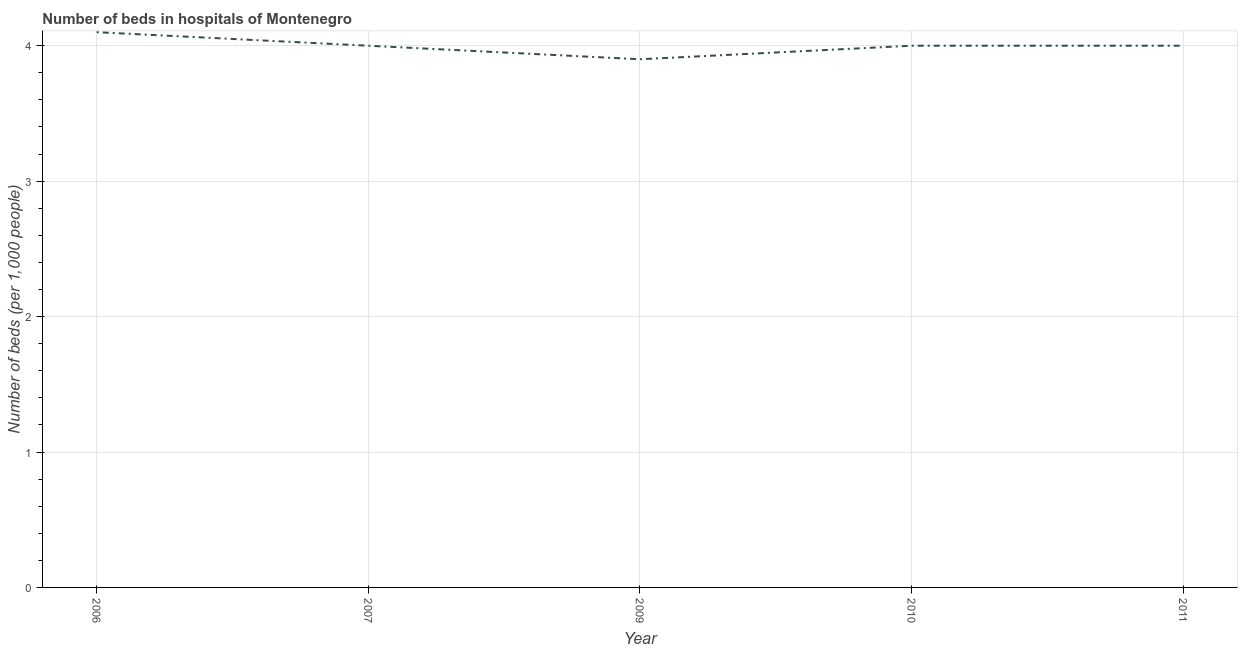What is the number of hospital beds in 2009?
Give a very brief answer. 3.9. In which year was the number of hospital beds maximum?
Keep it short and to the point. 2006. Do a majority of the years between 2010 and 2006 (inclusive) have number of hospital beds greater than 2 %?
Offer a very short reply. Yes. What is the ratio of the number of hospital beds in 2006 to that in 2010?
Offer a terse response. 1.02. What is the difference between the highest and the second highest number of hospital beds?
Give a very brief answer. 0.1. What is the difference between the highest and the lowest number of hospital beds?
Your answer should be very brief. 0.2. In how many years, is the number of hospital beds greater than the average number of hospital beds taken over all years?
Keep it short and to the point. 1. Does the number of hospital beds monotonically increase over the years?
Your answer should be very brief. No. How many lines are there?
Your answer should be very brief. 1. What is the difference between two consecutive major ticks on the Y-axis?
Keep it short and to the point. 1. Are the values on the major ticks of Y-axis written in scientific E-notation?
Ensure brevity in your answer.  No. Does the graph contain any zero values?
Make the answer very short. No. What is the title of the graph?
Keep it short and to the point. Number of beds in hospitals of Montenegro. What is the label or title of the X-axis?
Provide a short and direct response. Year. What is the label or title of the Y-axis?
Offer a very short reply. Number of beds (per 1,0 people). What is the Number of beds (per 1,000 people) in 2006?
Make the answer very short. 4.1. What is the Number of beds (per 1,000 people) of 2007?
Keep it short and to the point. 4. What is the Number of beds (per 1,000 people) in 2009?
Your answer should be compact. 3.9. What is the Number of beds (per 1,000 people) of 2011?
Keep it short and to the point. 4. What is the difference between the Number of beds (per 1,000 people) in 2006 and 2009?
Offer a terse response. 0.2. What is the difference between the Number of beds (per 1,000 people) in 2006 and 2010?
Give a very brief answer. 0.1. What is the difference between the Number of beds (per 1,000 people) in 2007 and 2011?
Ensure brevity in your answer.  0. What is the difference between the Number of beds (per 1,000 people) in 2010 and 2011?
Offer a terse response. 0. What is the ratio of the Number of beds (per 1,000 people) in 2006 to that in 2009?
Make the answer very short. 1.05. What is the ratio of the Number of beds (per 1,000 people) in 2006 to that in 2010?
Keep it short and to the point. 1.02. What is the ratio of the Number of beds (per 1,000 people) in 2007 to that in 2009?
Offer a terse response. 1.03. What is the ratio of the Number of beds (per 1,000 people) in 2007 to that in 2010?
Ensure brevity in your answer.  1. What is the ratio of the Number of beds (per 1,000 people) in 2007 to that in 2011?
Keep it short and to the point. 1. 